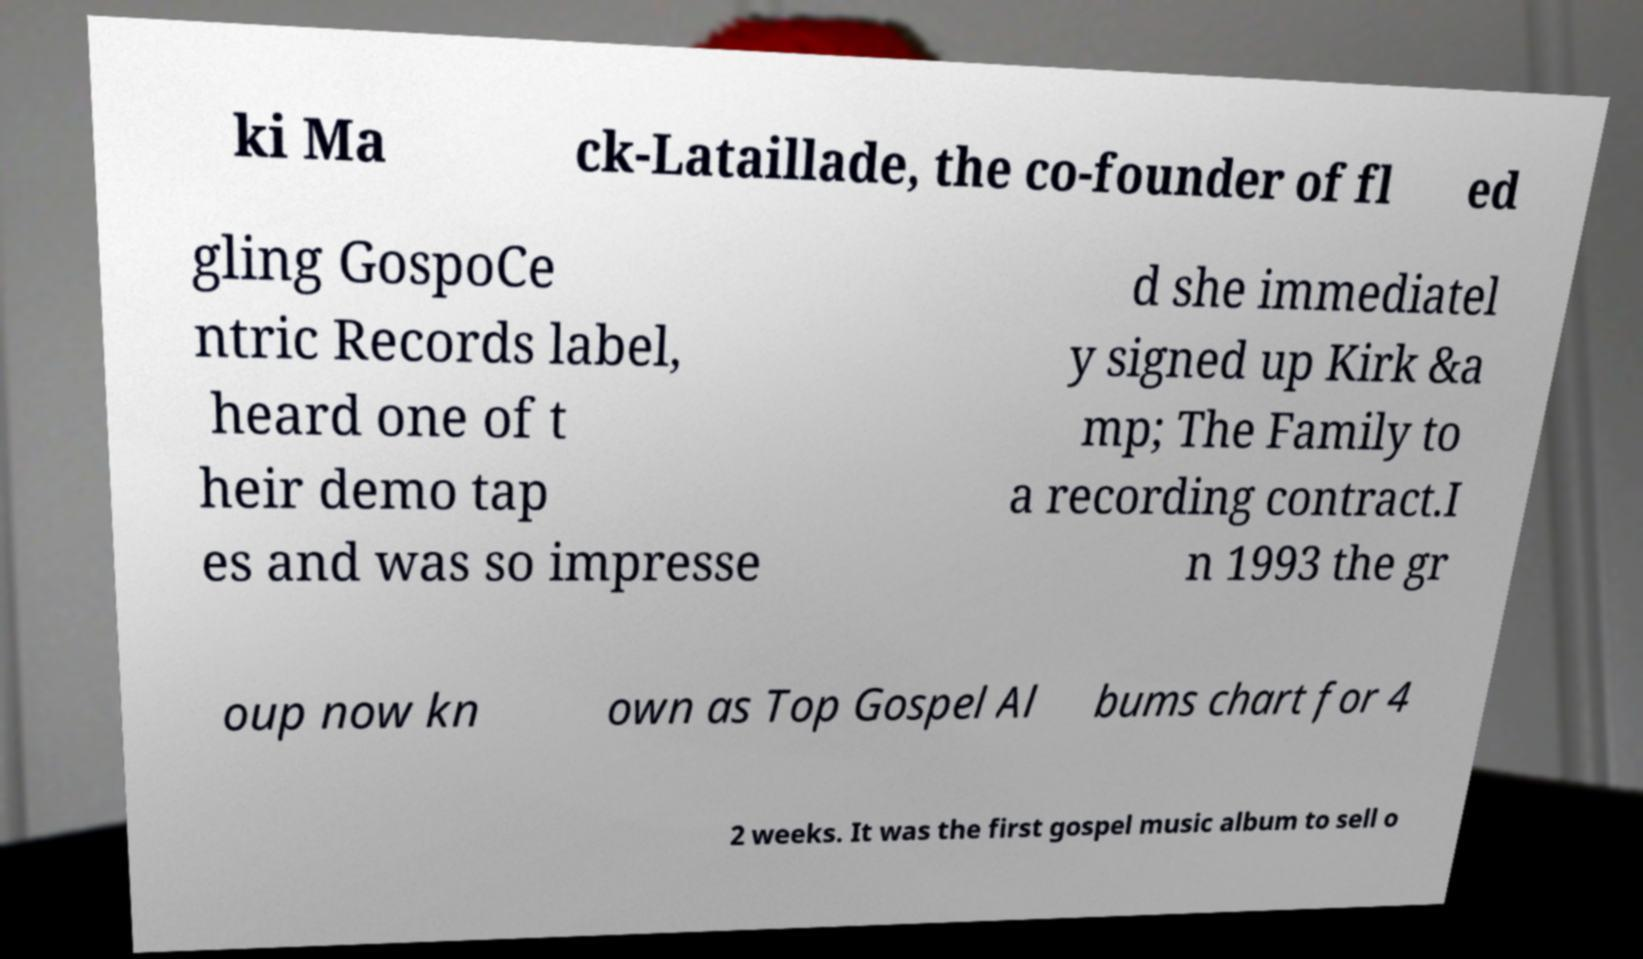There's text embedded in this image that I need extracted. Can you transcribe it verbatim? ki Ma ck-Lataillade, the co-founder of fl ed gling GospoCe ntric Records label, heard one of t heir demo tap es and was so impresse d she immediatel y signed up Kirk &a mp; The Family to a recording contract.I n 1993 the gr oup now kn own as Top Gospel Al bums chart for 4 2 weeks. It was the first gospel music album to sell o 